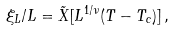<formula> <loc_0><loc_0><loc_500><loc_500>\xi _ { L } / L = { \tilde { X } } [ L ^ { 1 / \nu } ( T - T _ { c } ) ] \, ,</formula> 